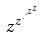<formula> <loc_0><loc_0><loc_500><loc_500>z ^ { z ^ { \cdot ^ { \cdot ^ { z ^ { z } } } } }</formula> 